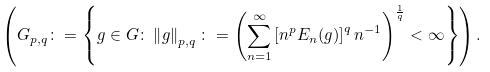Convert formula to latex. <formula><loc_0><loc_0><loc_500><loc_500>\left ( G _ { p , q } \colon = \left \{ g \in G \colon \left \| g \right \| _ { p , q } \colon = \left ( \overset { \infty } { \underset { n = 1 } { \sum } } \left [ n ^ { p } E _ { n } ( g ) \right ] ^ { q } n ^ { - 1 } \right ) ^ { \frac { 1 } { q } } < \infty \right \} \right ) .</formula> 